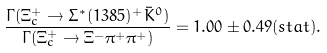Convert formula to latex. <formula><loc_0><loc_0><loc_500><loc_500>\frac { \Gamma ( \Xi _ { c } ^ { + } \rightarrow \Sigma ^ { * } ( 1 3 8 5 ) ^ { + } \bar { K } ^ { 0 } ) } { \Gamma ( \Xi _ { c } ^ { + } \rightarrow \Xi ^ { - } \pi ^ { + } \pi ^ { + } ) } = 1 . 0 0 \pm 0 . 4 9 ( s t a t ) .</formula> 